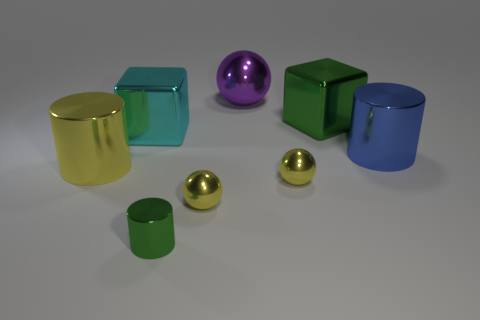Is the number of large metallic cylinders in front of the big blue cylinder greater than the number of yellow shiny objects that are to the left of the small metallic cylinder?
Offer a very short reply. No. Are there any small gray objects that have the same shape as the small green object?
Make the answer very short. No. What size is the green shiny thing in front of the big metal thing that is on the right side of the large green shiny block?
Offer a terse response. Small. The cyan thing that is to the left of the large metallic sphere right of the shiny cylinder that is on the left side of the big cyan block is what shape?
Your answer should be compact. Cube. The cyan object that is the same material as the purple thing is what size?
Provide a short and direct response. Large. Is the number of large green blocks greater than the number of yellow matte objects?
Offer a very short reply. Yes. What is the material of the purple thing that is the same size as the yellow metal cylinder?
Ensure brevity in your answer.  Metal. Does the metallic ball behind the yellow cylinder have the same size as the yellow cylinder?
Give a very brief answer. Yes. What number of balls are large blue things or large green metallic things?
Provide a short and direct response. 0. There is a tiny yellow thing to the right of the purple ball; what is it made of?
Offer a very short reply. Metal. 